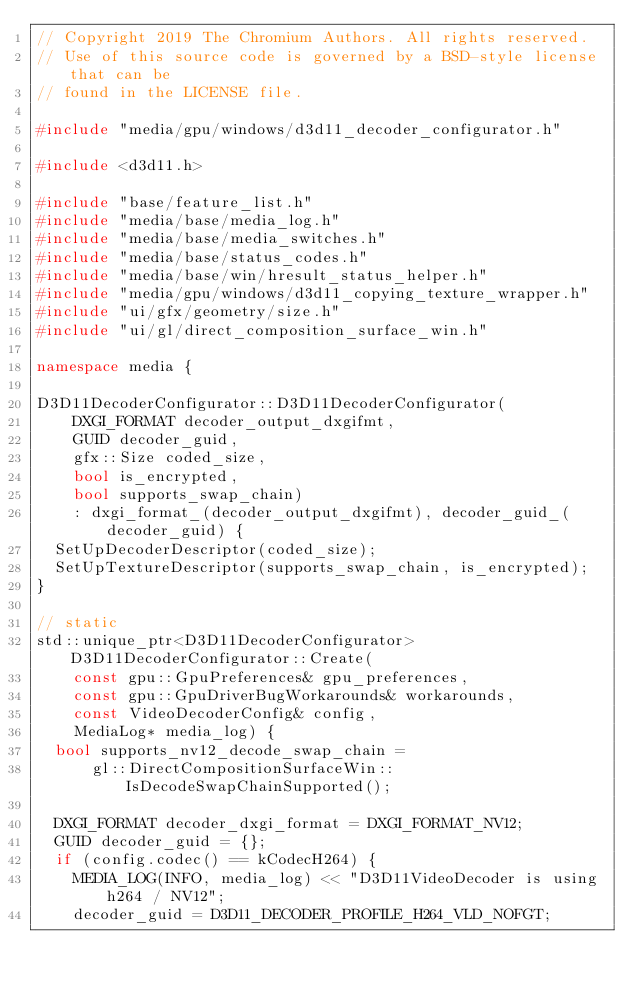Convert code to text. <code><loc_0><loc_0><loc_500><loc_500><_C++_>// Copyright 2019 The Chromium Authors. All rights reserved.
// Use of this source code is governed by a BSD-style license that can be
// found in the LICENSE file.

#include "media/gpu/windows/d3d11_decoder_configurator.h"

#include <d3d11.h>

#include "base/feature_list.h"
#include "media/base/media_log.h"
#include "media/base/media_switches.h"
#include "media/base/status_codes.h"
#include "media/base/win/hresult_status_helper.h"
#include "media/gpu/windows/d3d11_copying_texture_wrapper.h"
#include "ui/gfx/geometry/size.h"
#include "ui/gl/direct_composition_surface_win.h"

namespace media {

D3D11DecoderConfigurator::D3D11DecoderConfigurator(
    DXGI_FORMAT decoder_output_dxgifmt,
    GUID decoder_guid,
    gfx::Size coded_size,
    bool is_encrypted,
    bool supports_swap_chain)
    : dxgi_format_(decoder_output_dxgifmt), decoder_guid_(decoder_guid) {
  SetUpDecoderDescriptor(coded_size);
  SetUpTextureDescriptor(supports_swap_chain, is_encrypted);
}

// static
std::unique_ptr<D3D11DecoderConfigurator> D3D11DecoderConfigurator::Create(
    const gpu::GpuPreferences& gpu_preferences,
    const gpu::GpuDriverBugWorkarounds& workarounds,
    const VideoDecoderConfig& config,
    MediaLog* media_log) {
  bool supports_nv12_decode_swap_chain =
      gl::DirectCompositionSurfaceWin::IsDecodeSwapChainSupported();

  DXGI_FORMAT decoder_dxgi_format = DXGI_FORMAT_NV12;
  GUID decoder_guid = {};
  if (config.codec() == kCodecH264) {
    MEDIA_LOG(INFO, media_log) << "D3D11VideoDecoder is using h264 / NV12";
    decoder_guid = D3D11_DECODER_PROFILE_H264_VLD_NOFGT;</code> 